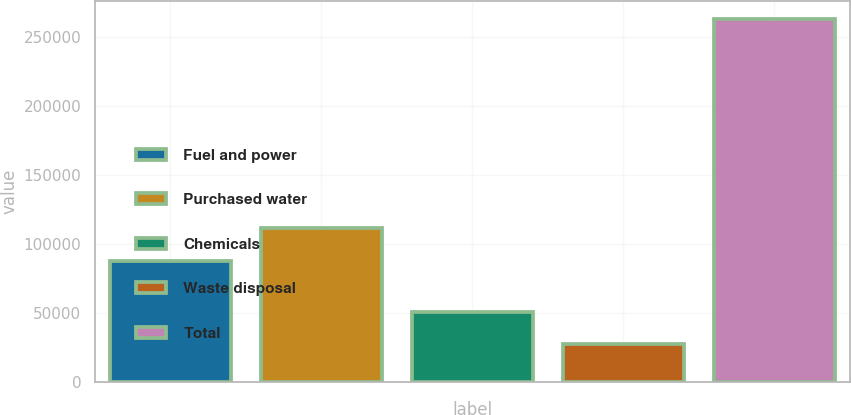Convert chart to OTSL. <chart><loc_0><loc_0><loc_500><loc_500><bar_chart><fcel>Fuel and power<fcel>Purchased water<fcel>Chemicals<fcel>Waste disposal<fcel>Total<nl><fcel>87879<fcel>111403<fcel>50846.1<fcel>27322<fcel>262563<nl></chart> 